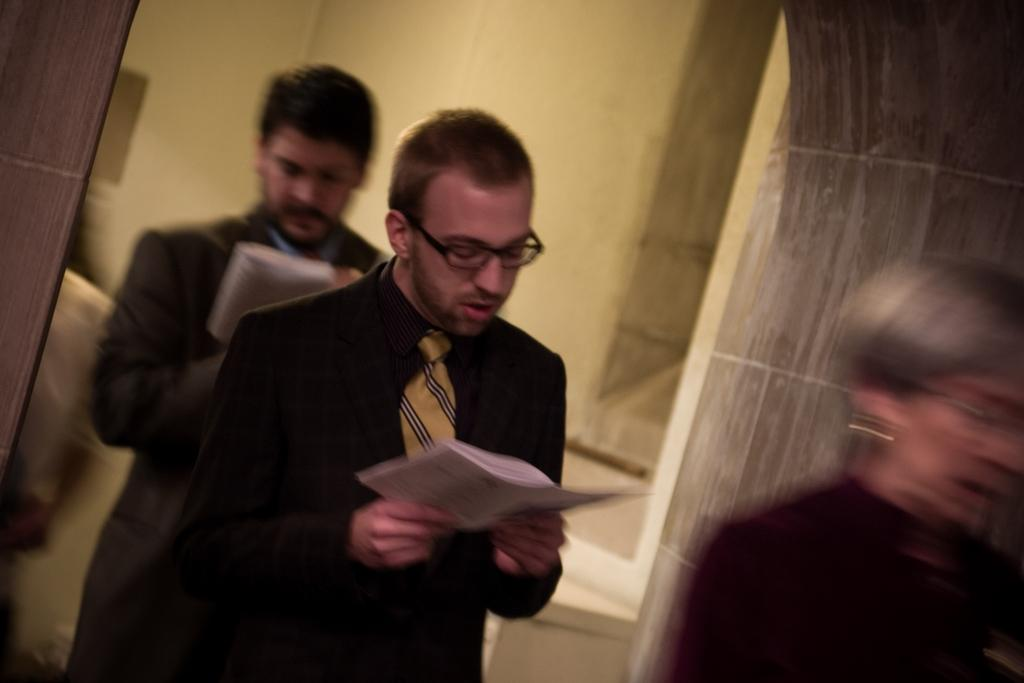What are the people in the image doing? The people in the image are standing. Can you describe any specific features of the people? Some of the people are wearing glasses, and some are holding papers in their hands. What is visible in the background of the image? There is a wall in the background of the image. What type of sleet can be seen falling in the image? There is no sleet present in the image; it is a picture of people standing. Can you describe the shape of the glasses the people are wearing? The provided facts do not mention the shape of the glasses, only that some people are wearing them. 